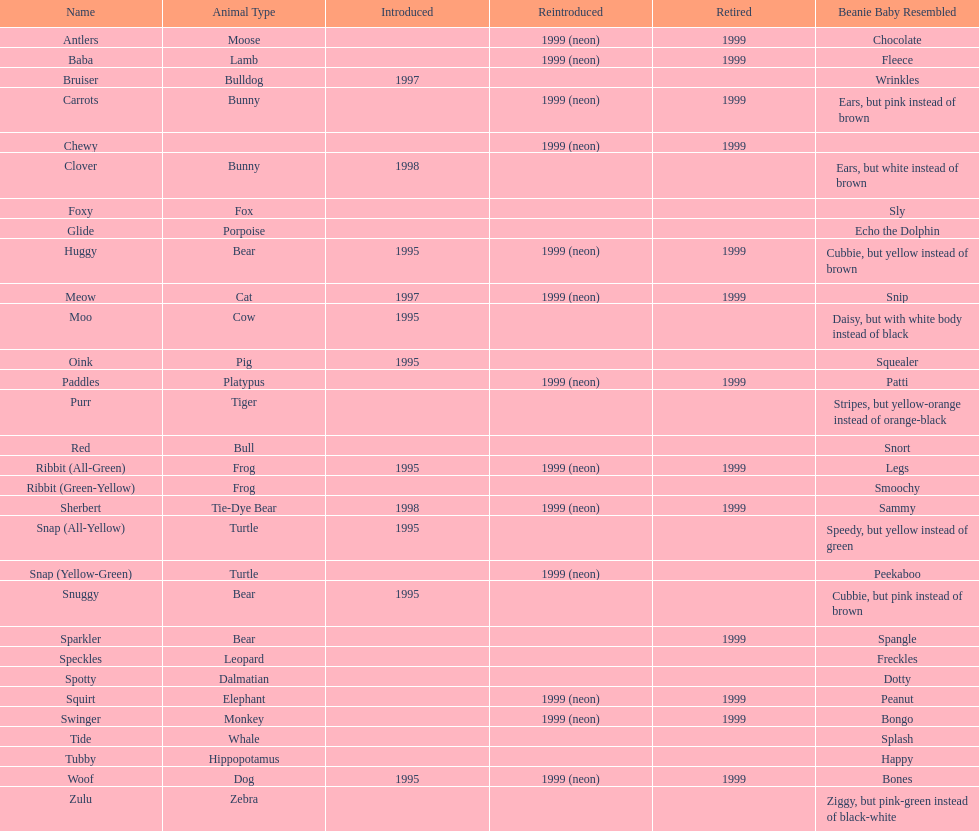How many pillow pals are there in total on this chart? 30. 